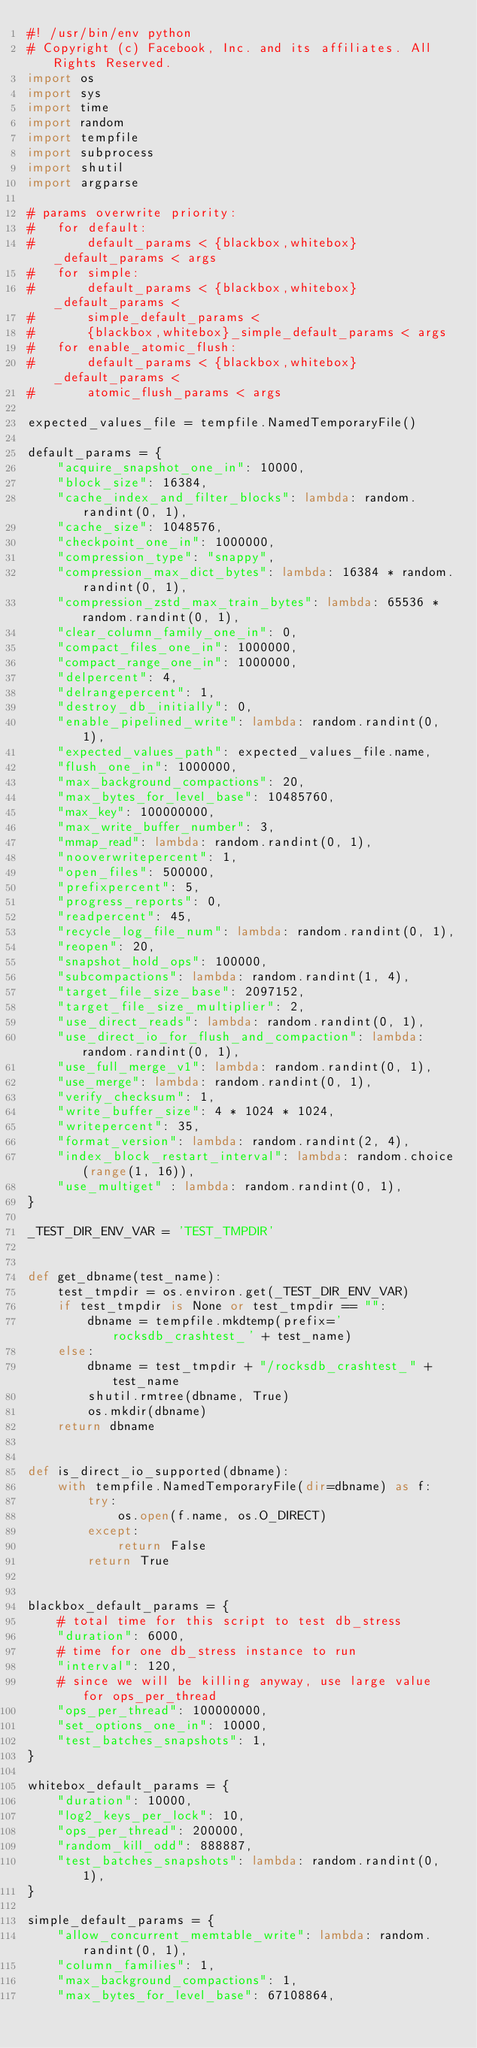Convert code to text. <code><loc_0><loc_0><loc_500><loc_500><_Python_>#! /usr/bin/env python
# Copyright (c) Facebook, Inc. and its affiliates. All Rights Reserved.
import os
import sys
import time
import random
import tempfile
import subprocess
import shutil
import argparse

# params overwrite priority:
#   for default:
#       default_params < {blackbox,whitebox}_default_params < args
#   for simple:
#       default_params < {blackbox,whitebox}_default_params <
#       simple_default_params <
#       {blackbox,whitebox}_simple_default_params < args
#   for enable_atomic_flush:
#       default_params < {blackbox,whitebox}_default_params <
#       atomic_flush_params < args

expected_values_file = tempfile.NamedTemporaryFile()

default_params = {
    "acquire_snapshot_one_in": 10000,
    "block_size": 16384,
    "cache_index_and_filter_blocks": lambda: random.randint(0, 1),
    "cache_size": 1048576,
    "checkpoint_one_in": 1000000,
    "compression_type": "snappy",
    "compression_max_dict_bytes": lambda: 16384 * random.randint(0, 1),
    "compression_zstd_max_train_bytes": lambda: 65536 * random.randint(0, 1),
    "clear_column_family_one_in": 0,
    "compact_files_one_in": 1000000,
    "compact_range_one_in": 1000000,
    "delpercent": 4,
    "delrangepercent": 1,
    "destroy_db_initially": 0,
    "enable_pipelined_write": lambda: random.randint(0, 1),
    "expected_values_path": expected_values_file.name,
    "flush_one_in": 1000000,
    "max_background_compactions": 20,
    "max_bytes_for_level_base": 10485760,
    "max_key": 100000000,
    "max_write_buffer_number": 3,
    "mmap_read": lambda: random.randint(0, 1),
    "nooverwritepercent": 1,
    "open_files": 500000,
    "prefixpercent": 5,
    "progress_reports": 0,
    "readpercent": 45,
    "recycle_log_file_num": lambda: random.randint(0, 1),
    "reopen": 20,
    "snapshot_hold_ops": 100000,
    "subcompactions": lambda: random.randint(1, 4),
    "target_file_size_base": 2097152,
    "target_file_size_multiplier": 2,
    "use_direct_reads": lambda: random.randint(0, 1),
    "use_direct_io_for_flush_and_compaction": lambda: random.randint(0, 1),
    "use_full_merge_v1": lambda: random.randint(0, 1),
    "use_merge": lambda: random.randint(0, 1),
    "verify_checksum": 1,
    "write_buffer_size": 4 * 1024 * 1024,
    "writepercent": 35,
    "format_version": lambda: random.randint(2, 4),
    "index_block_restart_interval": lambda: random.choice(range(1, 16)),
    "use_multiget" : lambda: random.randint(0, 1),
}

_TEST_DIR_ENV_VAR = 'TEST_TMPDIR'


def get_dbname(test_name):
    test_tmpdir = os.environ.get(_TEST_DIR_ENV_VAR)
    if test_tmpdir is None or test_tmpdir == "":
        dbname = tempfile.mkdtemp(prefix='rocksdb_crashtest_' + test_name)
    else:
        dbname = test_tmpdir + "/rocksdb_crashtest_" + test_name
        shutil.rmtree(dbname, True)
        os.mkdir(dbname)
    return dbname


def is_direct_io_supported(dbname):
    with tempfile.NamedTemporaryFile(dir=dbname) as f:
        try:
            os.open(f.name, os.O_DIRECT)
        except:
            return False
        return True


blackbox_default_params = {
    # total time for this script to test db_stress
    "duration": 6000,
    # time for one db_stress instance to run
    "interval": 120,
    # since we will be killing anyway, use large value for ops_per_thread
    "ops_per_thread": 100000000,
    "set_options_one_in": 10000,
    "test_batches_snapshots": 1,
}

whitebox_default_params = {
    "duration": 10000,
    "log2_keys_per_lock": 10,
    "ops_per_thread": 200000,
    "random_kill_odd": 888887,
    "test_batches_snapshots": lambda: random.randint(0, 1),
}

simple_default_params = {
    "allow_concurrent_memtable_write": lambda: random.randint(0, 1),
    "column_families": 1,
    "max_background_compactions": 1,
    "max_bytes_for_level_base": 67108864,</code> 